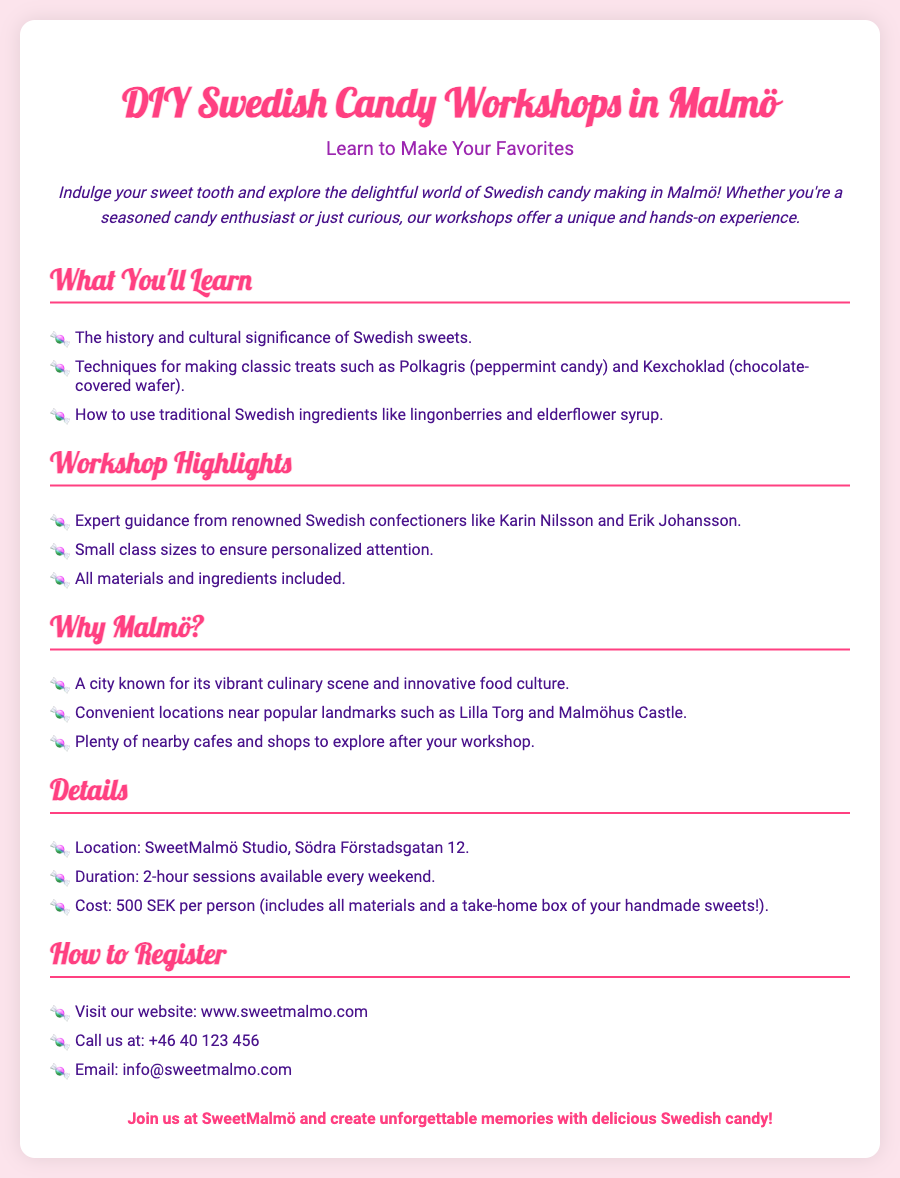What is the location of the workshop? The location of the workshop is specified in the details section of the document as SweetMalmö Studio, Södra Förstadsgatan 12.
Answer: SweetMalmö Studio, Södra Förstadsgatan 12 Who are the renowned Swedish confectioners mentioned? The document lists Karin Nilsson and Erik Johansson as the expert guidance for the workshops.
Answer: Karin Nilsson and Erik Johansson What is the duration of each session? The details section states that the duration of each session is a 2-hour session.
Answer: 2-hour sessions How much does the workshop cost? The cost of the workshop is given as 500 SEK per person according to the details section.
Answer: 500 SEK What traditional ingredients will be used in the workshop? The document mentions using traditional Swedish ingredients such as lingonberries and elderflower syrup.
Answer: Lingonberries and elderflower syrup Why is Malmö chosen for the workshops? The document highlights Malmö's vibrant culinary scene and innovative food culture as reasons for the location of the workshops.
Answer: Vibrant culinary scene and innovative food culture How can participants register for the workshop? The ways to register are provided in the document, including visiting the website, calling, or emailing.
Answer: Visit the website, call, or email What is included in the workshop cost? The document states that the workshop cost includes all materials and a take-home box of handmade sweets.
Answer: All materials and a take-home box of handmade sweets 